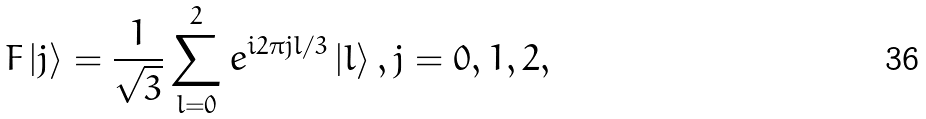<formula> <loc_0><loc_0><loc_500><loc_500>F \left | j \right \rangle = \frac { 1 } { \sqrt { 3 } } \sum _ { l = 0 } ^ { 2 } e ^ { i 2 \pi j l / 3 } \left | l \right \rangle , j = 0 , 1 , 2 ,</formula> 